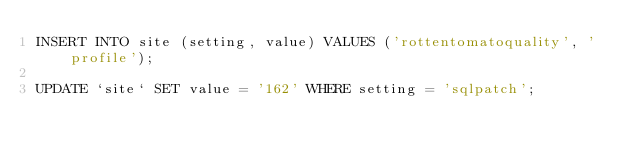Convert code to text. <code><loc_0><loc_0><loc_500><loc_500><_SQL_>INSERT INTO site (setting, value) VALUES ('rottentomatoquality', 'profile');

UPDATE `site` SET value = '162' WHERE setting = 'sqlpatch';
</code> 